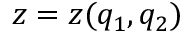<formula> <loc_0><loc_0><loc_500><loc_500>z = z ( q _ { 1 } , q _ { 2 } )</formula> 